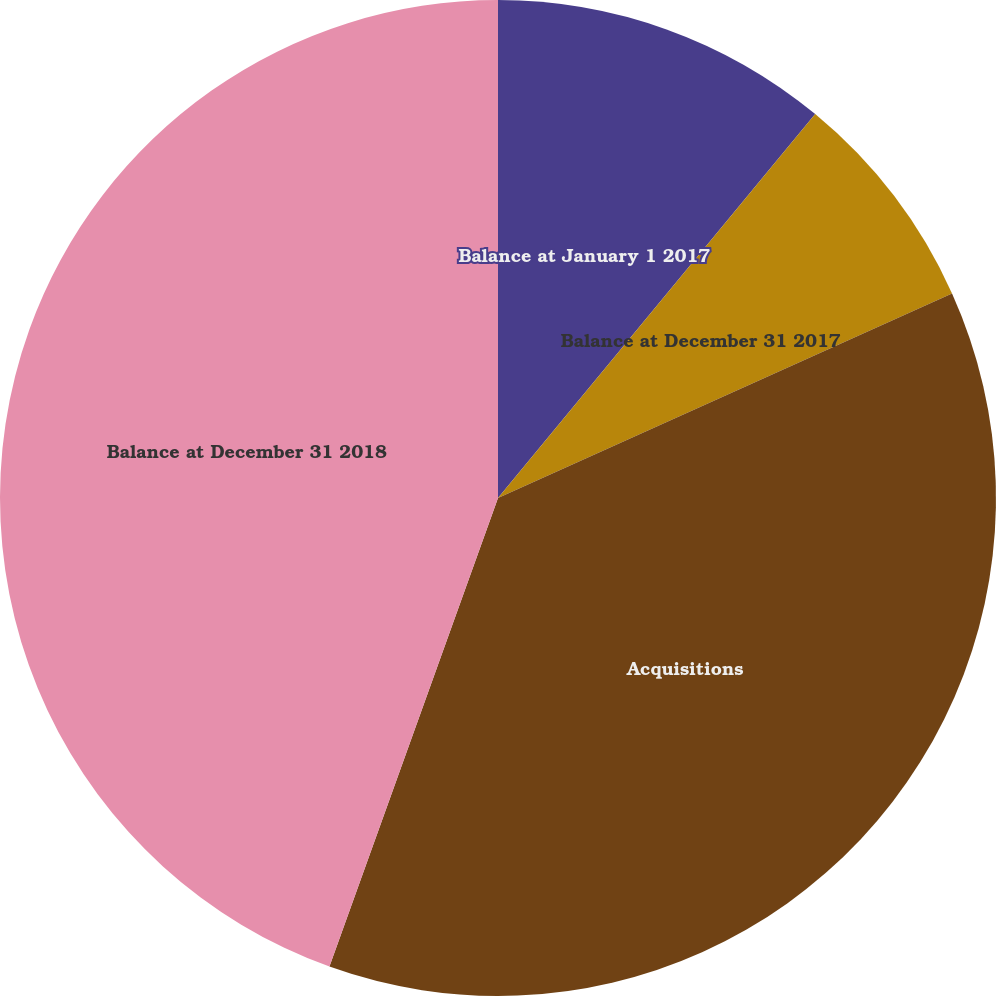<chart> <loc_0><loc_0><loc_500><loc_500><pie_chart><fcel>Balance at January 1 2017<fcel>Balance at December 31 2017<fcel>Acquisitions<fcel>Balance at December 31 2018<nl><fcel>10.99%<fcel>7.27%<fcel>37.23%<fcel>44.5%<nl></chart> 